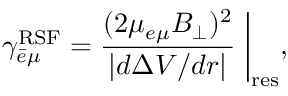Convert formula to latex. <formula><loc_0><loc_0><loc_500><loc_500>\gamma _ { \bar { e } \mu } ^ { R S F } = \frac { ( 2 \mu _ { e \mu } B _ { \perp } ) ^ { 2 } } { | d \Delta V / d r | } \Big | _ { r e s } ,</formula> 